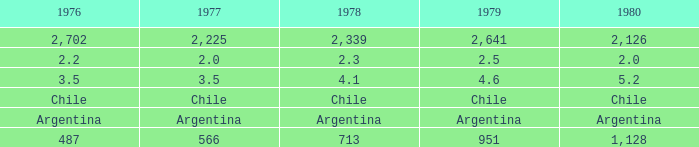What is 1977 when 1980 is chile? Chile. Can you parse all the data within this table? {'header': ['1976', '1977', '1978', '1979', '1980'], 'rows': [['2,702', '2,225', '2,339', '2,641', '2,126'], ['2.2', '2.0', '2.3', '2.5', '2.0'], ['3.5', '3.5', '4.1', '4.6', '5.2'], ['Chile', 'Chile', 'Chile', 'Chile', 'Chile'], ['Argentina', 'Argentina', 'Argentina', 'Argentina', 'Argentina'], ['487', '566', '713', '951', '1,128']]} 